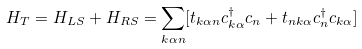<formula> <loc_0><loc_0><loc_500><loc_500>H _ { T } = H _ { L S } + H _ { R S } = \sum _ { k \alpha n } [ t _ { k \alpha n } c _ { k \alpha } ^ { \dag } c _ { n } + t _ { n k \alpha } c _ { n } ^ { \dag } c _ { k \alpha } ]</formula> 